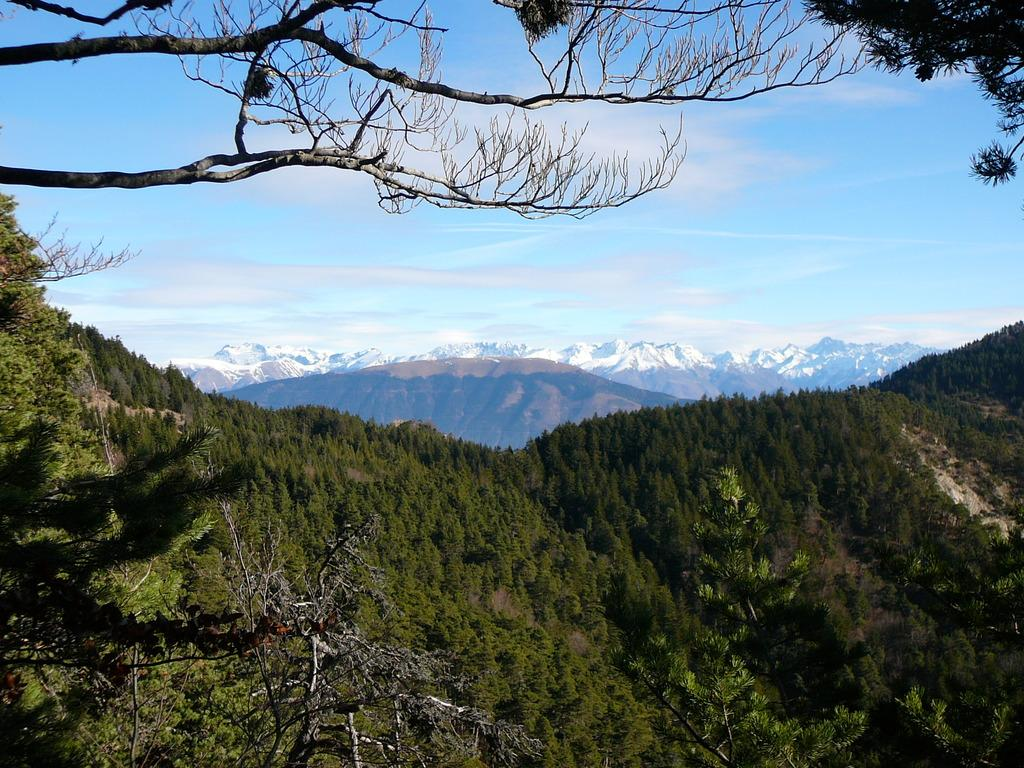What type of vegetation can be seen on the hill in the image? There are trees on a hill in the image. What other geographical features can be seen in the background? There are hills visible in the background. What part of the natural environment is visible in the image? The sky is visible in the image. What is the condition of the sky in the image? Clouds are present in the sky. What is the name of the nation where the trees on the hill are located? The provided facts do not mention the name of the nation where the trees on the hill are located. 